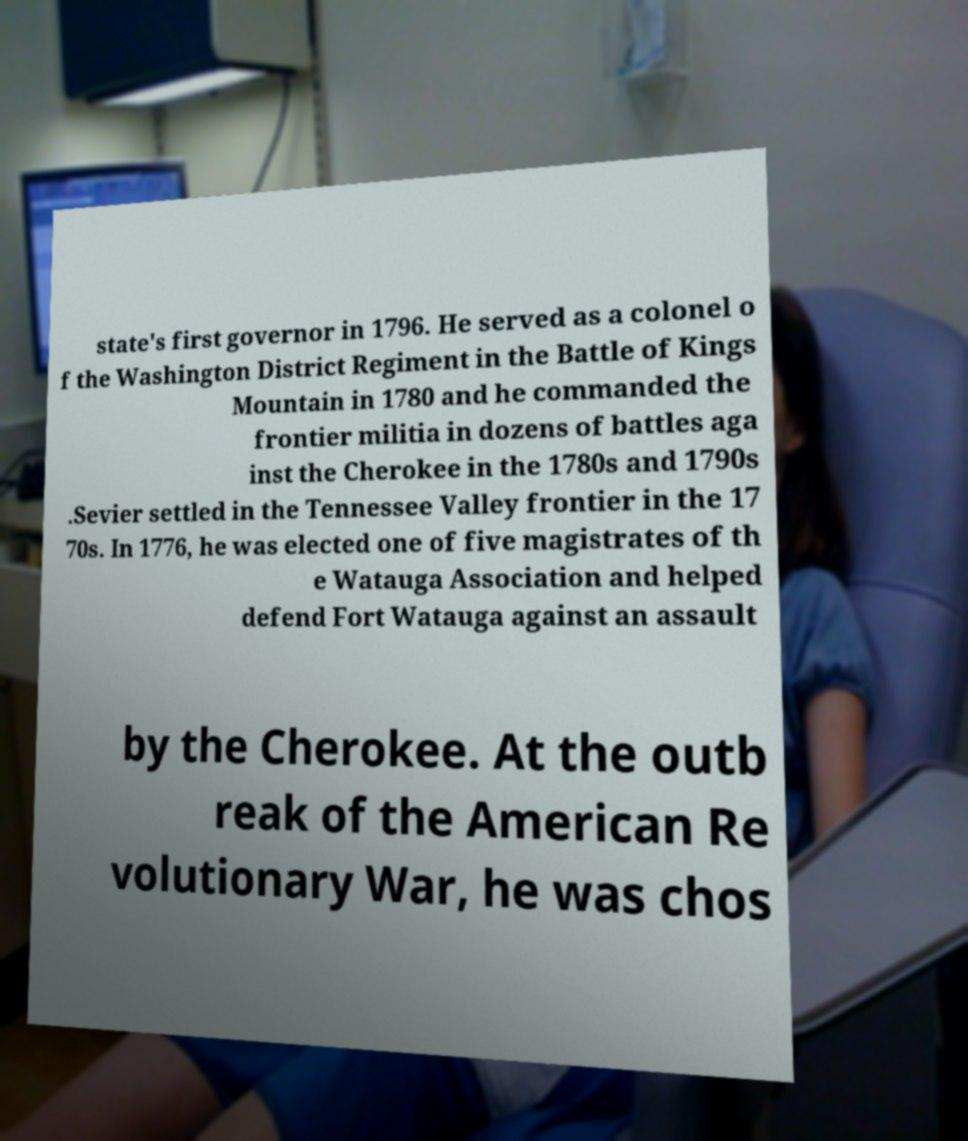Please identify and transcribe the text found in this image. state's first governor in 1796. He served as a colonel o f the Washington District Regiment in the Battle of Kings Mountain in 1780 and he commanded the frontier militia in dozens of battles aga inst the Cherokee in the 1780s and 1790s .Sevier settled in the Tennessee Valley frontier in the 17 70s. In 1776, he was elected one of five magistrates of th e Watauga Association and helped defend Fort Watauga against an assault by the Cherokee. At the outb reak of the American Re volutionary War, he was chos 